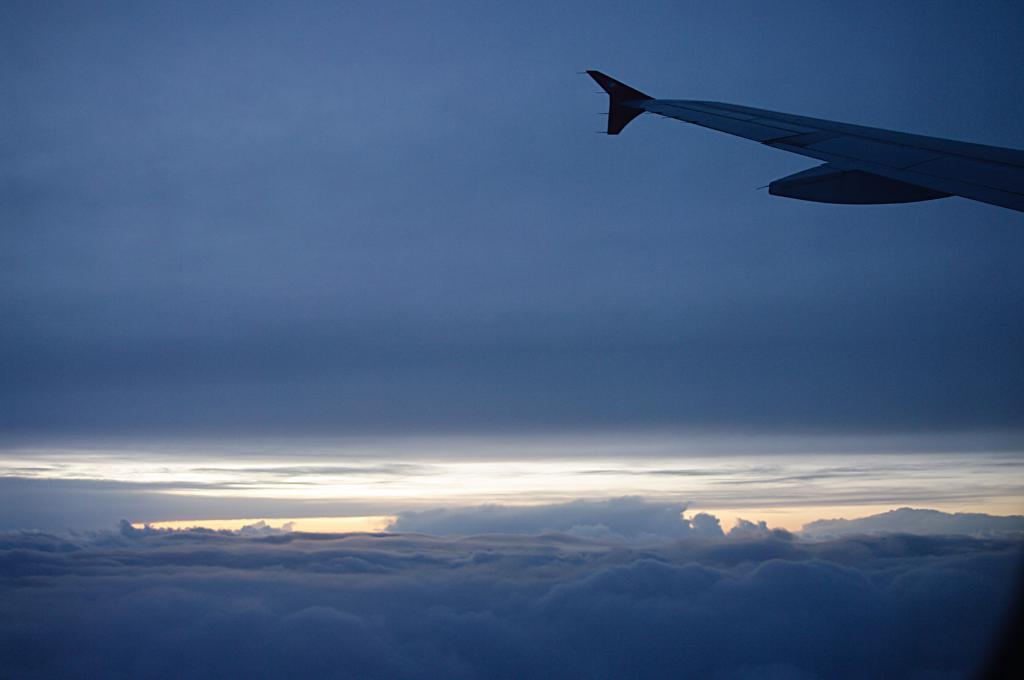What is located at the bottom of the image? There are clouds at the bottom of the image. What can be seen on the right side of the image? There is a wing of a plane on the right side of the image. What is visible at the top of the image? There is a sky visible at the top of the image. What type of loss is depicted in the image? There is no depiction of loss in the image; it features clouds, a wing of a plane, and a sky. Can you tell me where the tail of the plane is located in the image? The tail of the plane is not visible in the image; only the wing is present. 